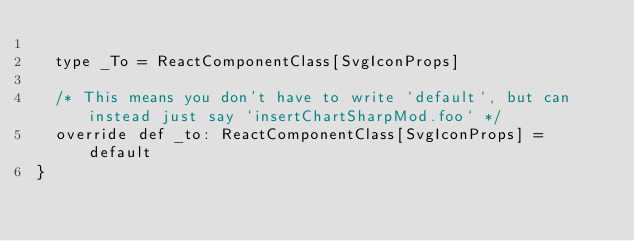Convert code to text. <code><loc_0><loc_0><loc_500><loc_500><_Scala_>  
  type _To = ReactComponentClass[SvgIconProps]
  
  /* This means you don't have to write `default`, but can instead just say `insertChartSharpMod.foo` */
  override def _to: ReactComponentClass[SvgIconProps] = default
}
</code> 